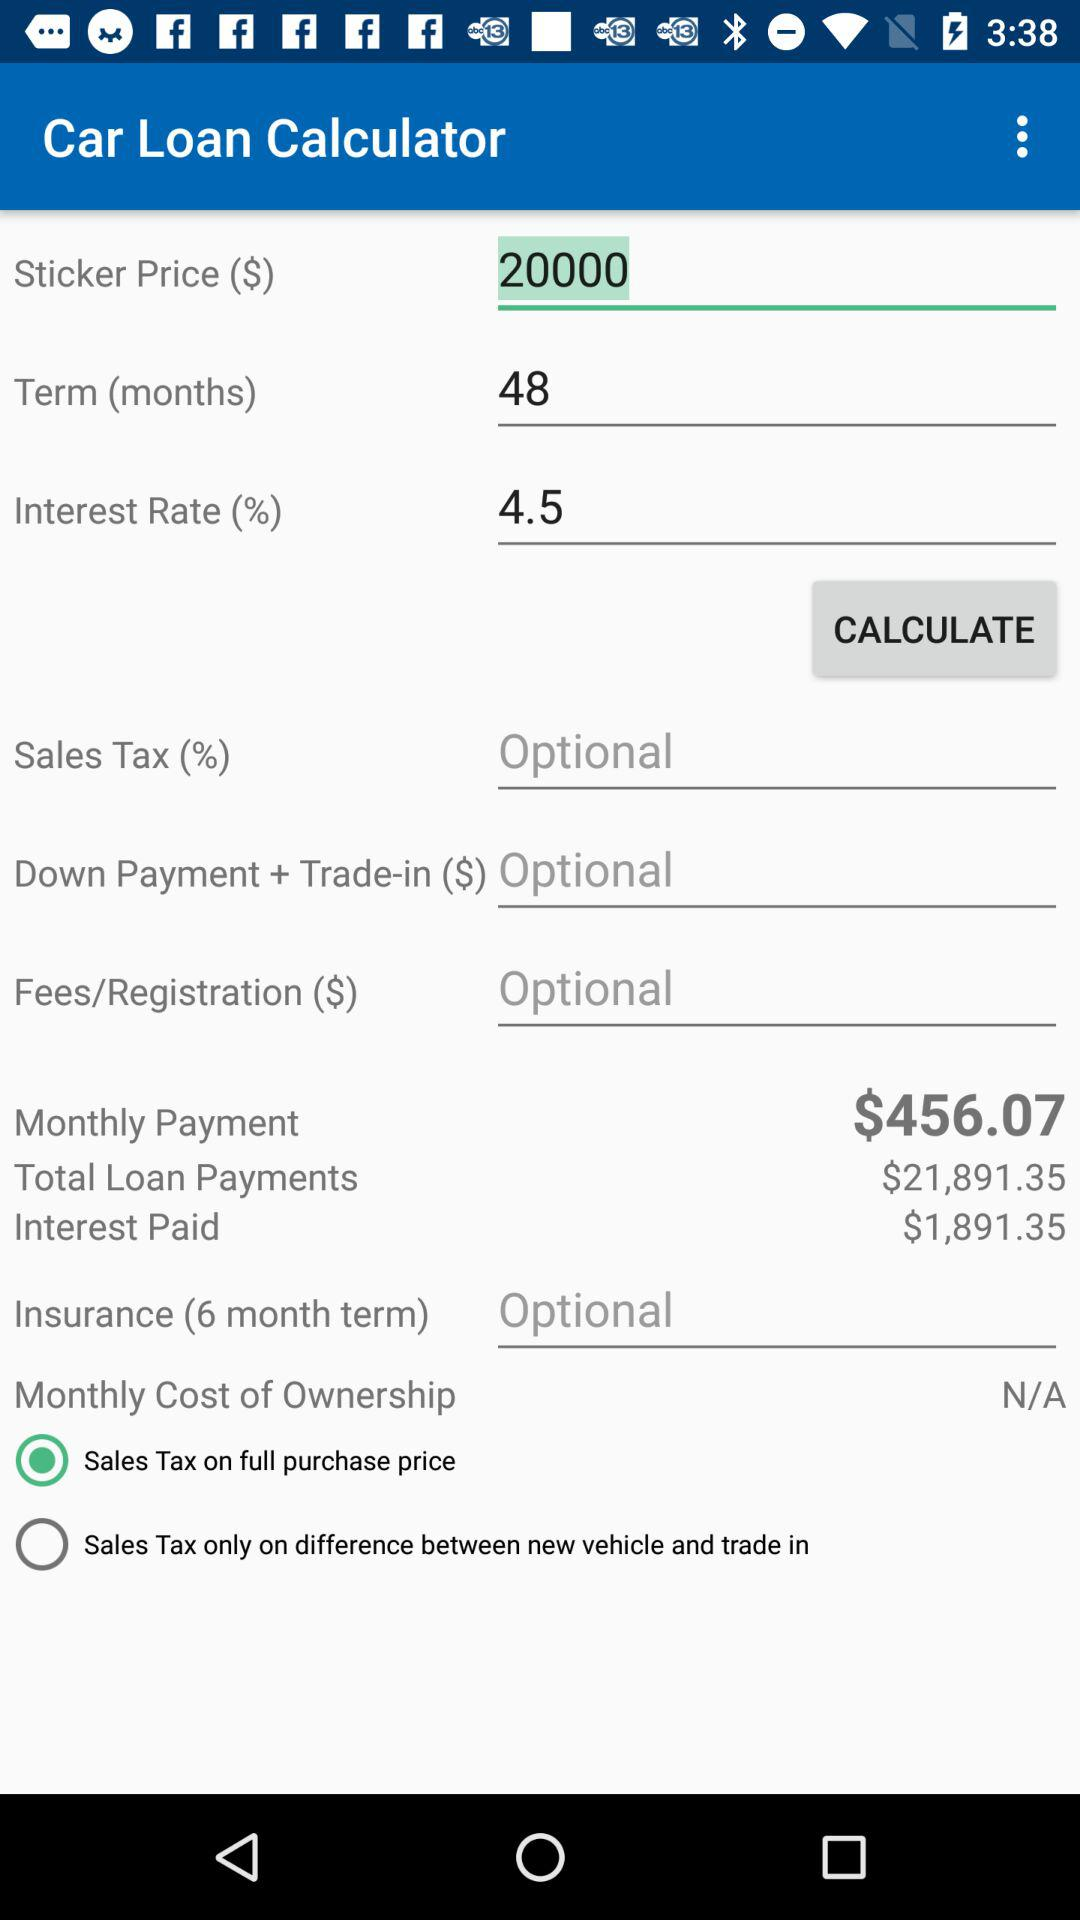What is the status of the sales tax on the full purchase price? The status is on. 